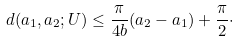Convert formula to latex. <formula><loc_0><loc_0><loc_500><loc_500>d ( a _ { 1 } , a _ { 2 } ; U ) \leq \frac { \pi } { 4 b } ( a _ { 2 } - a _ { 1 } ) + \frac { \pi } { 2 } \cdot</formula> 